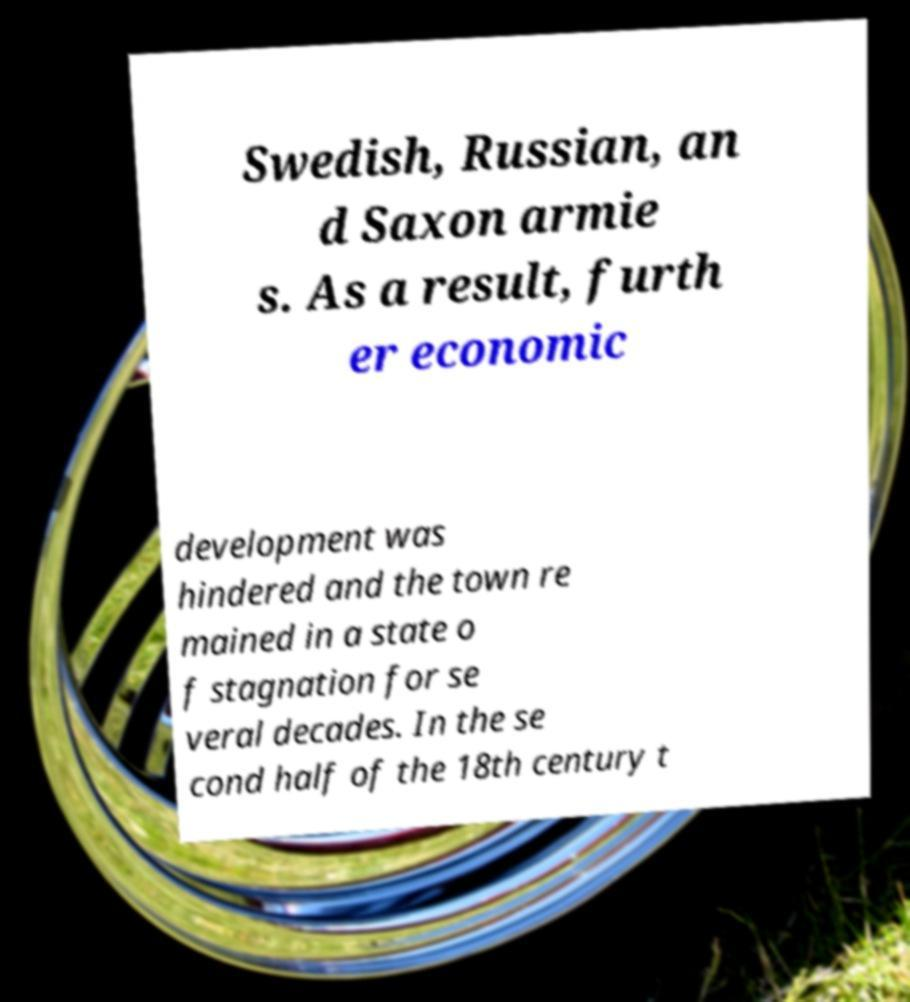Can you accurately transcribe the text from the provided image for me? Swedish, Russian, an d Saxon armie s. As a result, furth er economic development was hindered and the town re mained in a state o f stagnation for se veral decades. In the se cond half of the 18th century t 